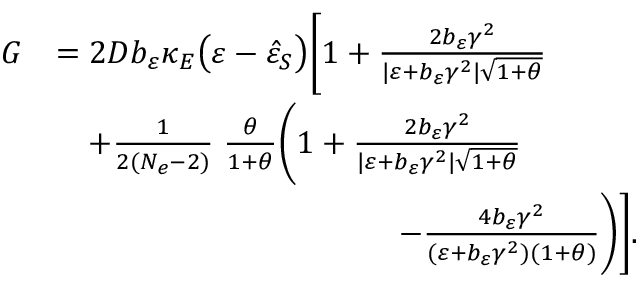Convert formula to latex. <formula><loc_0><loc_0><loc_500><loc_500>\begin{array} { r l } { G } & { = 2 D b _ { \varepsilon } \kappa _ { E } \left ( \varepsilon - \hat { \varepsilon } _ { S } \right ) \left [ 1 + \frac { 2 b _ { \varepsilon } \gamma ^ { 2 } } { | \varepsilon + b _ { \varepsilon } \gamma ^ { 2 } | \sqrt { 1 + \theta } } } \\ & { \quad + \frac { 1 } { 2 ( N _ { e } - 2 ) } \, \frac { \theta } { 1 + \theta } \left ( 1 + \frac { 2 b _ { \varepsilon } \gamma ^ { 2 } } { | \varepsilon + b _ { \varepsilon } \gamma ^ { 2 } | \sqrt { 1 + \theta } } } \\ & { \quad \, - \frac { 4 b _ { \varepsilon } \gamma ^ { 2 } } { ( \varepsilon + b _ { \varepsilon } \gamma ^ { 2 } ) ( 1 + \theta ) } \right ) \right ] . } \end{array}</formula> 